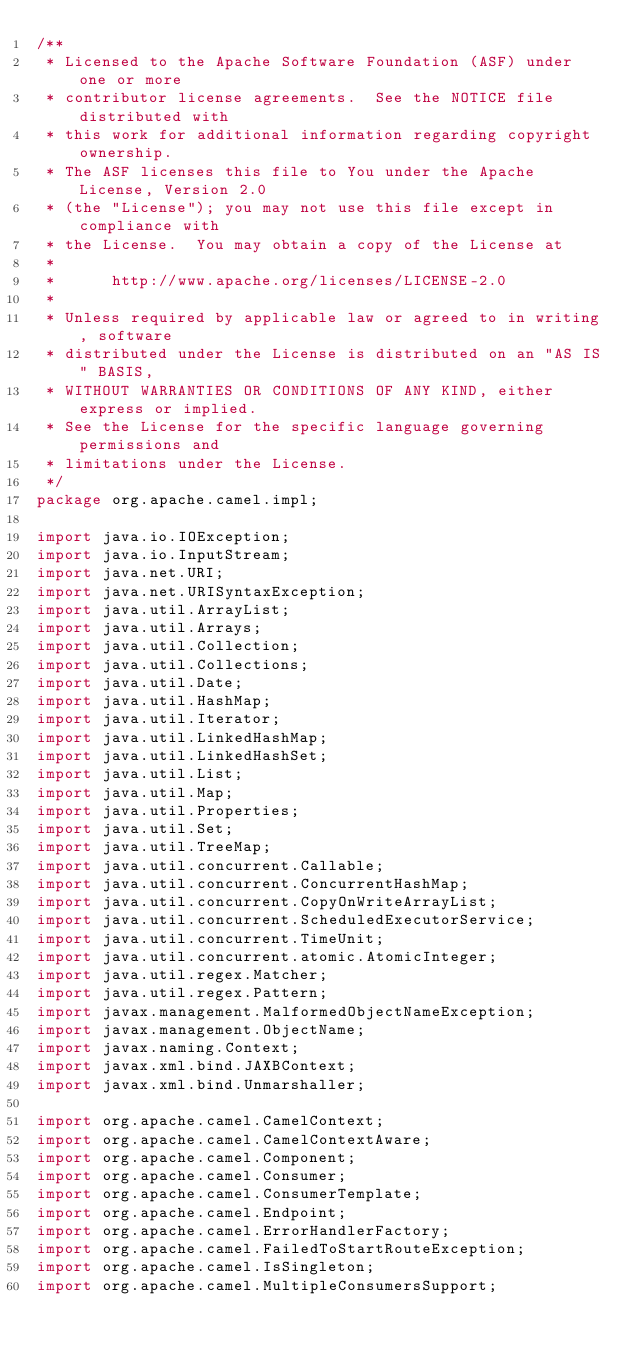Convert code to text. <code><loc_0><loc_0><loc_500><loc_500><_Java_>/**
 * Licensed to the Apache Software Foundation (ASF) under one or more
 * contributor license agreements.  See the NOTICE file distributed with
 * this work for additional information regarding copyright ownership.
 * The ASF licenses this file to You under the Apache License, Version 2.0
 * (the "License"); you may not use this file except in compliance with
 * the License.  You may obtain a copy of the License at
 *
 *      http://www.apache.org/licenses/LICENSE-2.0
 *
 * Unless required by applicable law or agreed to in writing, software
 * distributed under the License is distributed on an "AS IS" BASIS,
 * WITHOUT WARRANTIES OR CONDITIONS OF ANY KIND, either express or implied.
 * See the License for the specific language governing permissions and
 * limitations under the License.
 */
package org.apache.camel.impl;

import java.io.IOException;
import java.io.InputStream;
import java.net.URI;
import java.net.URISyntaxException;
import java.util.ArrayList;
import java.util.Arrays;
import java.util.Collection;
import java.util.Collections;
import java.util.Date;
import java.util.HashMap;
import java.util.Iterator;
import java.util.LinkedHashMap;
import java.util.LinkedHashSet;
import java.util.List;
import java.util.Map;
import java.util.Properties;
import java.util.Set;
import java.util.TreeMap;
import java.util.concurrent.Callable;
import java.util.concurrent.ConcurrentHashMap;
import java.util.concurrent.CopyOnWriteArrayList;
import java.util.concurrent.ScheduledExecutorService;
import java.util.concurrent.TimeUnit;
import java.util.concurrent.atomic.AtomicInteger;
import java.util.regex.Matcher;
import java.util.regex.Pattern;
import javax.management.MalformedObjectNameException;
import javax.management.ObjectName;
import javax.naming.Context;
import javax.xml.bind.JAXBContext;
import javax.xml.bind.Unmarshaller;

import org.apache.camel.CamelContext;
import org.apache.camel.CamelContextAware;
import org.apache.camel.Component;
import org.apache.camel.Consumer;
import org.apache.camel.ConsumerTemplate;
import org.apache.camel.Endpoint;
import org.apache.camel.ErrorHandlerFactory;
import org.apache.camel.FailedToStartRouteException;
import org.apache.camel.IsSingleton;
import org.apache.camel.MultipleConsumersSupport;</code> 